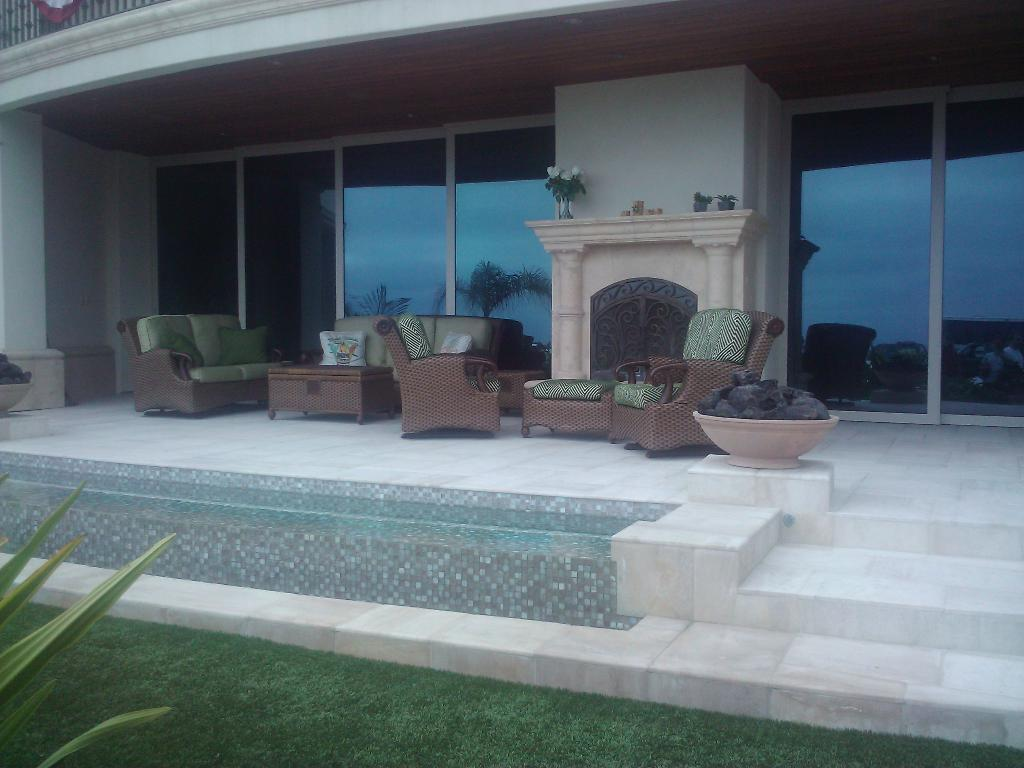What type of structure is shown in the image? The image depicts a building. What feature can be seen on the building? There are windows in the building. What decorative items are present in the image? Flower vases are present in the image. What type of seating is visible in the image? There are empty sofas and chairs with pillows in the image. What type of vegetation is present in the image? There is fresh green grass in the image. How is the water distributed in the basin in the image? There is no basin or water present in the image; it features a building with windows, flower vases, empty sofas, chairs with pillows, and fresh green grass. 